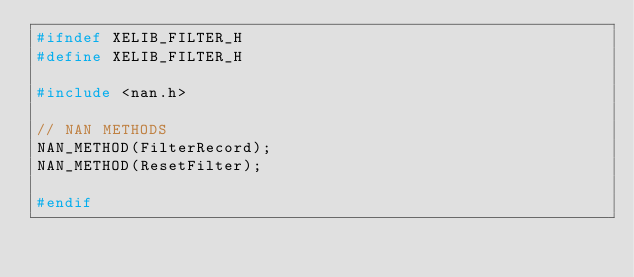Convert code to text. <code><loc_0><loc_0><loc_500><loc_500><_C_>#ifndef XELIB_FILTER_H
#define XELIB_FILTER_H

#include <nan.h>

// NAN METHODS
NAN_METHOD(FilterRecord);
NAN_METHOD(ResetFilter);

#endif</code> 